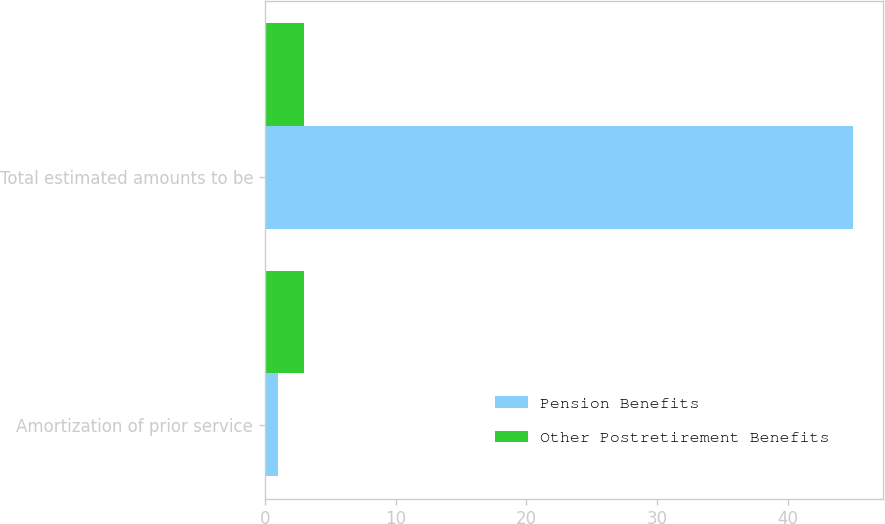Convert chart to OTSL. <chart><loc_0><loc_0><loc_500><loc_500><stacked_bar_chart><ecel><fcel>Amortization of prior service<fcel>Total estimated amounts to be<nl><fcel>Pension Benefits<fcel>1<fcel>45<nl><fcel>Other Postretirement Benefits<fcel>3<fcel>3<nl></chart> 